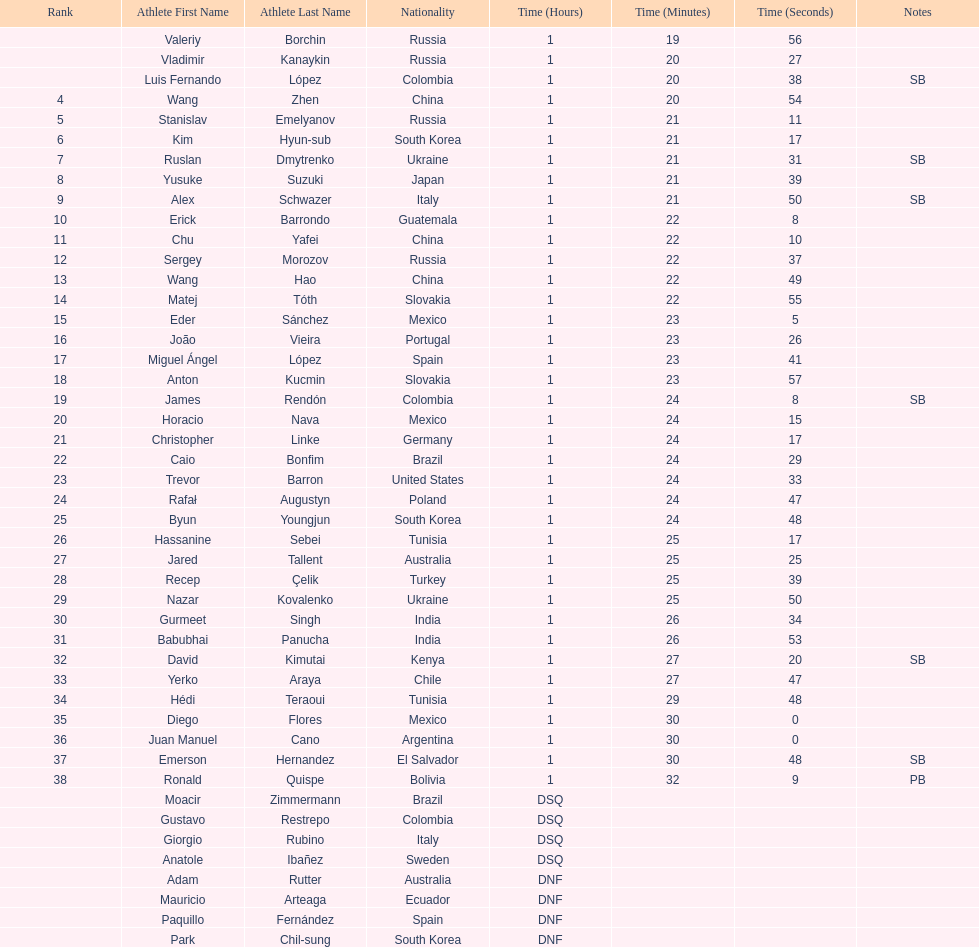Name all athletes were slower than horacio nava. Christopher Linke, Caio Bonfim, Trevor Barron, Rafał Augustyn, Byun Youngjun, Hassanine Sebei, Jared Tallent, Recep Çelik, Nazar Kovalenko, Gurmeet Singh, Babubhai Panucha, David Kimutai, Yerko Araya, Hédi Teraoui, Diego Flores, Juan Manuel Cano, Emerson Hernandez, Ronald Quispe. 